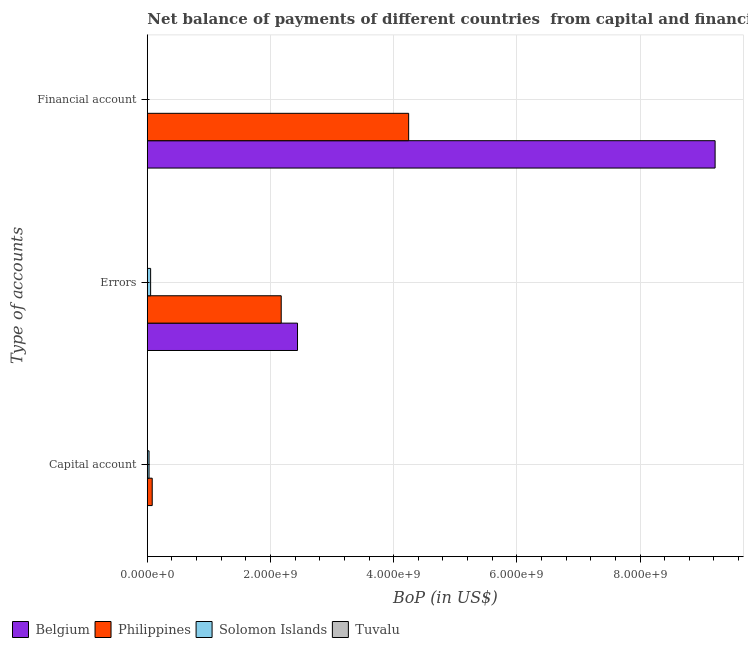How many groups of bars are there?
Your answer should be compact. 3. How many bars are there on the 1st tick from the top?
Provide a short and direct response. 3. What is the label of the 3rd group of bars from the top?
Keep it short and to the point. Capital account. What is the amount of errors in Solomon Islands?
Ensure brevity in your answer.  5.34e+07. Across all countries, what is the maximum amount of errors?
Offer a terse response. 2.44e+09. What is the total amount of financial account in the graph?
Offer a very short reply. 1.35e+1. What is the difference between the amount of errors in Solomon Islands and that in Philippines?
Your response must be concise. -2.12e+09. What is the difference between the amount of financial account in Solomon Islands and the amount of errors in Belgium?
Make the answer very short. -2.44e+09. What is the average amount of financial account per country?
Provide a short and direct response. 3.37e+09. What is the difference between the amount of errors and amount of financial account in Philippines?
Ensure brevity in your answer.  -2.07e+09. What is the ratio of the amount of financial account in Belgium to that in Philippines?
Your response must be concise. 2.17. What is the difference between the highest and the second highest amount of errors?
Offer a terse response. 2.65e+08. What is the difference between the highest and the lowest amount of errors?
Provide a succinct answer. 2.44e+09. In how many countries, is the amount of financial account greater than the average amount of financial account taken over all countries?
Provide a short and direct response. 2. Is the sum of the amount of errors in Philippines and Tuvalu greater than the maximum amount of financial account across all countries?
Keep it short and to the point. No. How many bars are there?
Make the answer very short. 10. What is the difference between two consecutive major ticks on the X-axis?
Make the answer very short. 2.00e+09. Are the values on the major ticks of X-axis written in scientific E-notation?
Make the answer very short. Yes. What is the title of the graph?
Provide a short and direct response. Net balance of payments of different countries  from capital and financial account. What is the label or title of the X-axis?
Keep it short and to the point. BoP (in US$). What is the label or title of the Y-axis?
Your answer should be very brief. Type of accounts. What is the BoP (in US$) of Belgium in Capital account?
Provide a short and direct response. 0. What is the BoP (in US$) of Philippines in Capital account?
Give a very brief answer. 7.93e+07. What is the BoP (in US$) of Solomon Islands in Capital account?
Provide a short and direct response. 2.77e+07. What is the BoP (in US$) in Tuvalu in Capital account?
Give a very brief answer. 2.42e+06. What is the BoP (in US$) in Belgium in Errors?
Your answer should be very brief. 2.44e+09. What is the BoP (in US$) in Philippines in Errors?
Offer a terse response. 2.17e+09. What is the BoP (in US$) of Solomon Islands in Errors?
Provide a short and direct response. 5.34e+07. What is the BoP (in US$) in Tuvalu in Errors?
Make the answer very short. 2.27e+06. What is the BoP (in US$) of Belgium in Financial account?
Your response must be concise. 9.22e+09. What is the BoP (in US$) of Philippines in Financial account?
Provide a succinct answer. 4.24e+09. What is the BoP (in US$) in Solomon Islands in Financial account?
Your response must be concise. 0. What is the BoP (in US$) of Tuvalu in Financial account?
Your answer should be compact. 4.11e+05. Across all Type of accounts, what is the maximum BoP (in US$) in Belgium?
Your answer should be very brief. 9.22e+09. Across all Type of accounts, what is the maximum BoP (in US$) in Philippines?
Ensure brevity in your answer.  4.24e+09. Across all Type of accounts, what is the maximum BoP (in US$) of Solomon Islands?
Provide a short and direct response. 5.34e+07. Across all Type of accounts, what is the maximum BoP (in US$) of Tuvalu?
Your answer should be very brief. 2.42e+06. Across all Type of accounts, what is the minimum BoP (in US$) of Philippines?
Provide a succinct answer. 7.93e+07. Across all Type of accounts, what is the minimum BoP (in US$) of Tuvalu?
Keep it short and to the point. 4.11e+05. What is the total BoP (in US$) of Belgium in the graph?
Make the answer very short. 1.17e+1. What is the total BoP (in US$) in Philippines in the graph?
Offer a terse response. 6.50e+09. What is the total BoP (in US$) in Solomon Islands in the graph?
Your answer should be very brief. 8.11e+07. What is the total BoP (in US$) in Tuvalu in the graph?
Ensure brevity in your answer.  5.10e+06. What is the difference between the BoP (in US$) of Philippines in Capital account and that in Errors?
Your answer should be compact. -2.09e+09. What is the difference between the BoP (in US$) of Solomon Islands in Capital account and that in Errors?
Keep it short and to the point. -2.57e+07. What is the difference between the BoP (in US$) of Tuvalu in Capital account and that in Errors?
Provide a short and direct response. 1.42e+05. What is the difference between the BoP (in US$) in Philippines in Capital account and that in Financial account?
Provide a succinct answer. -4.16e+09. What is the difference between the BoP (in US$) of Tuvalu in Capital account and that in Financial account?
Your response must be concise. 2.00e+06. What is the difference between the BoP (in US$) of Belgium in Errors and that in Financial account?
Make the answer very short. -6.78e+09. What is the difference between the BoP (in US$) in Philippines in Errors and that in Financial account?
Provide a succinct answer. -2.07e+09. What is the difference between the BoP (in US$) of Tuvalu in Errors and that in Financial account?
Your answer should be compact. 1.86e+06. What is the difference between the BoP (in US$) in Philippines in Capital account and the BoP (in US$) in Solomon Islands in Errors?
Provide a succinct answer. 2.59e+07. What is the difference between the BoP (in US$) in Philippines in Capital account and the BoP (in US$) in Tuvalu in Errors?
Keep it short and to the point. 7.70e+07. What is the difference between the BoP (in US$) of Solomon Islands in Capital account and the BoP (in US$) of Tuvalu in Errors?
Keep it short and to the point. 2.55e+07. What is the difference between the BoP (in US$) in Philippines in Capital account and the BoP (in US$) in Tuvalu in Financial account?
Offer a terse response. 7.89e+07. What is the difference between the BoP (in US$) in Solomon Islands in Capital account and the BoP (in US$) in Tuvalu in Financial account?
Keep it short and to the point. 2.73e+07. What is the difference between the BoP (in US$) in Belgium in Errors and the BoP (in US$) in Philippines in Financial account?
Give a very brief answer. -1.80e+09. What is the difference between the BoP (in US$) of Belgium in Errors and the BoP (in US$) of Tuvalu in Financial account?
Provide a short and direct response. 2.44e+09. What is the difference between the BoP (in US$) in Philippines in Errors and the BoP (in US$) in Tuvalu in Financial account?
Keep it short and to the point. 2.17e+09. What is the difference between the BoP (in US$) in Solomon Islands in Errors and the BoP (in US$) in Tuvalu in Financial account?
Give a very brief answer. 5.30e+07. What is the average BoP (in US$) of Belgium per Type of accounts?
Keep it short and to the point. 3.89e+09. What is the average BoP (in US$) of Philippines per Type of accounts?
Your answer should be compact. 2.17e+09. What is the average BoP (in US$) in Solomon Islands per Type of accounts?
Give a very brief answer. 2.70e+07. What is the average BoP (in US$) of Tuvalu per Type of accounts?
Offer a very short reply. 1.70e+06. What is the difference between the BoP (in US$) of Philippines and BoP (in US$) of Solomon Islands in Capital account?
Your answer should be compact. 5.15e+07. What is the difference between the BoP (in US$) in Philippines and BoP (in US$) in Tuvalu in Capital account?
Offer a terse response. 7.69e+07. What is the difference between the BoP (in US$) of Solomon Islands and BoP (in US$) of Tuvalu in Capital account?
Provide a short and direct response. 2.53e+07. What is the difference between the BoP (in US$) in Belgium and BoP (in US$) in Philippines in Errors?
Offer a terse response. 2.65e+08. What is the difference between the BoP (in US$) in Belgium and BoP (in US$) in Solomon Islands in Errors?
Your answer should be very brief. 2.39e+09. What is the difference between the BoP (in US$) in Belgium and BoP (in US$) in Tuvalu in Errors?
Your response must be concise. 2.44e+09. What is the difference between the BoP (in US$) in Philippines and BoP (in US$) in Solomon Islands in Errors?
Keep it short and to the point. 2.12e+09. What is the difference between the BoP (in US$) of Philippines and BoP (in US$) of Tuvalu in Errors?
Your answer should be compact. 2.17e+09. What is the difference between the BoP (in US$) of Solomon Islands and BoP (in US$) of Tuvalu in Errors?
Ensure brevity in your answer.  5.11e+07. What is the difference between the BoP (in US$) of Belgium and BoP (in US$) of Philippines in Financial account?
Offer a terse response. 4.98e+09. What is the difference between the BoP (in US$) in Belgium and BoP (in US$) in Tuvalu in Financial account?
Ensure brevity in your answer.  9.22e+09. What is the difference between the BoP (in US$) in Philippines and BoP (in US$) in Tuvalu in Financial account?
Offer a terse response. 4.24e+09. What is the ratio of the BoP (in US$) of Philippines in Capital account to that in Errors?
Provide a succinct answer. 0.04. What is the ratio of the BoP (in US$) in Solomon Islands in Capital account to that in Errors?
Keep it short and to the point. 0.52. What is the ratio of the BoP (in US$) in Tuvalu in Capital account to that in Errors?
Provide a succinct answer. 1.06. What is the ratio of the BoP (in US$) of Philippines in Capital account to that in Financial account?
Keep it short and to the point. 0.02. What is the ratio of the BoP (in US$) in Tuvalu in Capital account to that in Financial account?
Give a very brief answer. 5.87. What is the ratio of the BoP (in US$) of Belgium in Errors to that in Financial account?
Provide a succinct answer. 0.26. What is the ratio of the BoP (in US$) of Philippines in Errors to that in Financial account?
Your answer should be very brief. 0.51. What is the ratio of the BoP (in US$) in Tuvalu in Errors to that in Financial account?
Give a very brief answer. 5.53. What is the difference between the highest and the second highest BoP (in US$) of Philippines?
Ensure brevity in your answer.  2.07e+09. What is the difference between the highest and the second highest BoP (in US$) in Tuvalu?
Your answer should be compact. 1.42e+05. What is the difference between the highest and the lowest BoP (in US$) in Belgium?
Provide a short and direct response. 9.22e+09. What is the difference between the highest and the lowest BoP (in US$) of Philippines?
Ensure brevity in your answer.  4.16e+09. What is the difference between the highest and the lowest BoP (in US$) of Solomon Islands?
Offer a very short reply. 5.34e+07. What is the difference between the highest and the lowest BoP (in US$) of Tuvalu?
Your answer should be compact. 2.00e+06. 